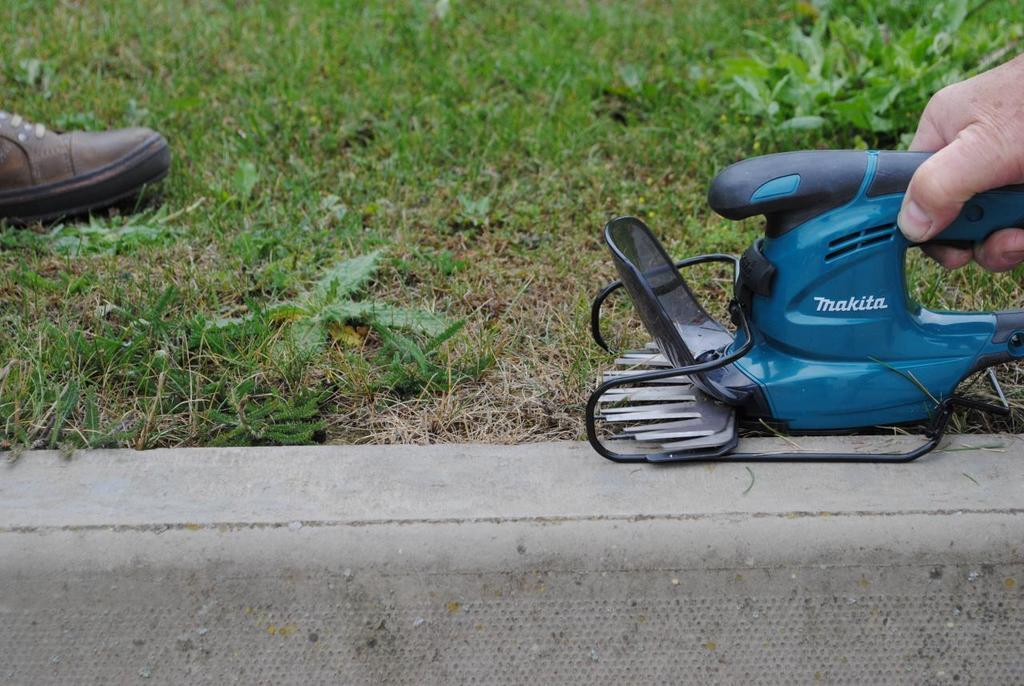What is the human hand holding in the image? There is a machine being held by a human hand in the image. What type of natural environment is visible in the image? There is grass at the top of the image, indicating a natural setting. What object can be seen on the left side of the image? There is a shoe on the left side of the image. How many brothers are visible in the image? There are no brothers present in the image. What type of town can be seen in the background of the image? There is no town visible in the image; it primarily features a human hand holding a machine and a natural setting with grass. 